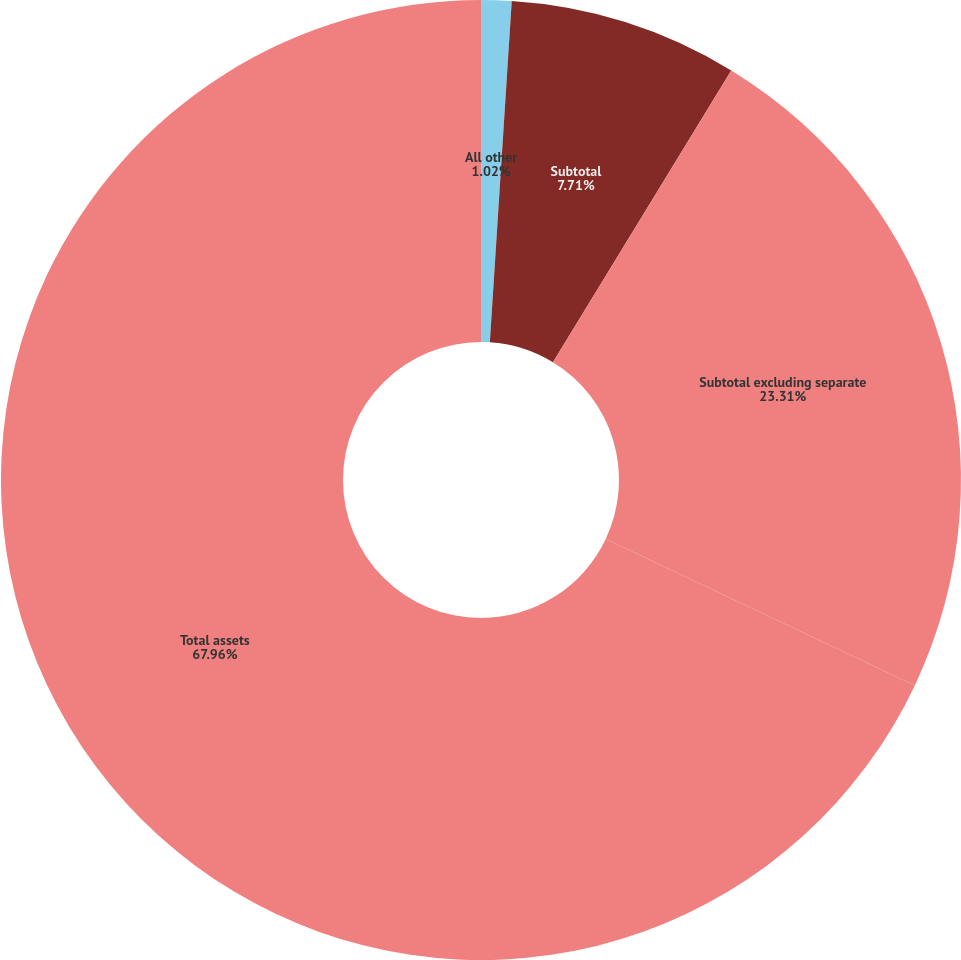<chart> <loc_0><loc_0><loc_500><loc_500><pie_chart><fcel>All other<fcel>Subtotal<fcel>Subtotal excluding separate<fcel>Total assets<nl><fcel>1.02%<fcel>7.71%<fcel>23.31%<fcel>67.97%<nl></chart> 